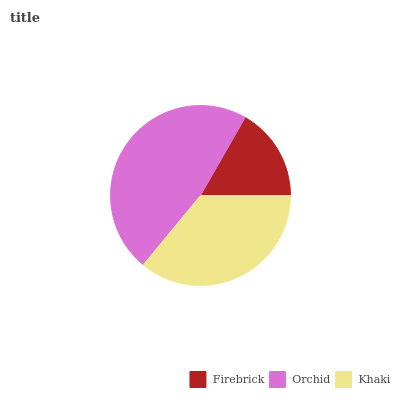Is Firebrick the minimum?
Answer yes or no. Yes. Is Orchid the maximum?
Answer yes or no. Yes. Is Khaki the minimum?
Answer yes or no. No. Is Khaki the maximum?
Answer yes or no. No. Is Orchid greater than Khaki?
Answer yes or no. Yes. Is Khaki less than Orchid?
Answer yes or no. Yes. Is Khaki greater than Orchid?
Answer yes or no. No. Is Orchid less than Khaki?
Answer yes or no. No. Is Khaki the high median?
Answer yes or no. Yes. Is Khaki the low median?
Answer yes or no. Yes. Is Orchid the high median?
Answer yes or no. No. Is Firebrick the low median?
Answer yes or no. No. 